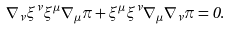<formula> <loc_0><loc_0><loc_500><loc_500>\nabla _ { \nu } \xi ^ { \nu } \xi ^ { \mu } \nabla _ { \mu } \pi + \xi ^ { \mu } \xi ^ { \nu } \nabla _ { \mu } \nabla _ { \nu } \pi = 0 .</formula> 